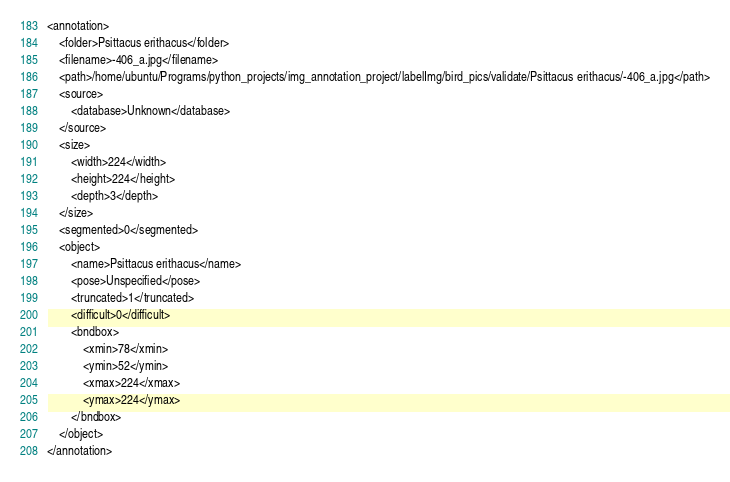Convert code to text. <code><loc_0><loc_0><loc_500><loc_500><_XML_><annotation>
	<folder>Psittacus erithacus</folder>
	<filename>-406_a.jpg</filename>
	<path>/home/ubuntu/Programs/python_projects/img_annotation_project/labelImg/bird_pics/validate/Psittacus erithacus/-406_a.jpg</path>
	<source>
		<database>Unknown</database>
	</source>
	<size>
		<width>224</width>
		<height>224</height>
		<depth>3</depth>
	</size>
	<segmented>0</segmented>
	<object>
		<name>Psittacus erithacus</name>
		<pose>Unspecified</pose>
		<truncated>1</truncated>
		<difficult>0</difficult>
		<bndbox>
			<xmin>78</xmin>
			<ymin>52</ymin>
			<xmax>224</xmax>
			<ymax>224</ymax>
		</bndbox>
	</object>
</annotation>
</code> 